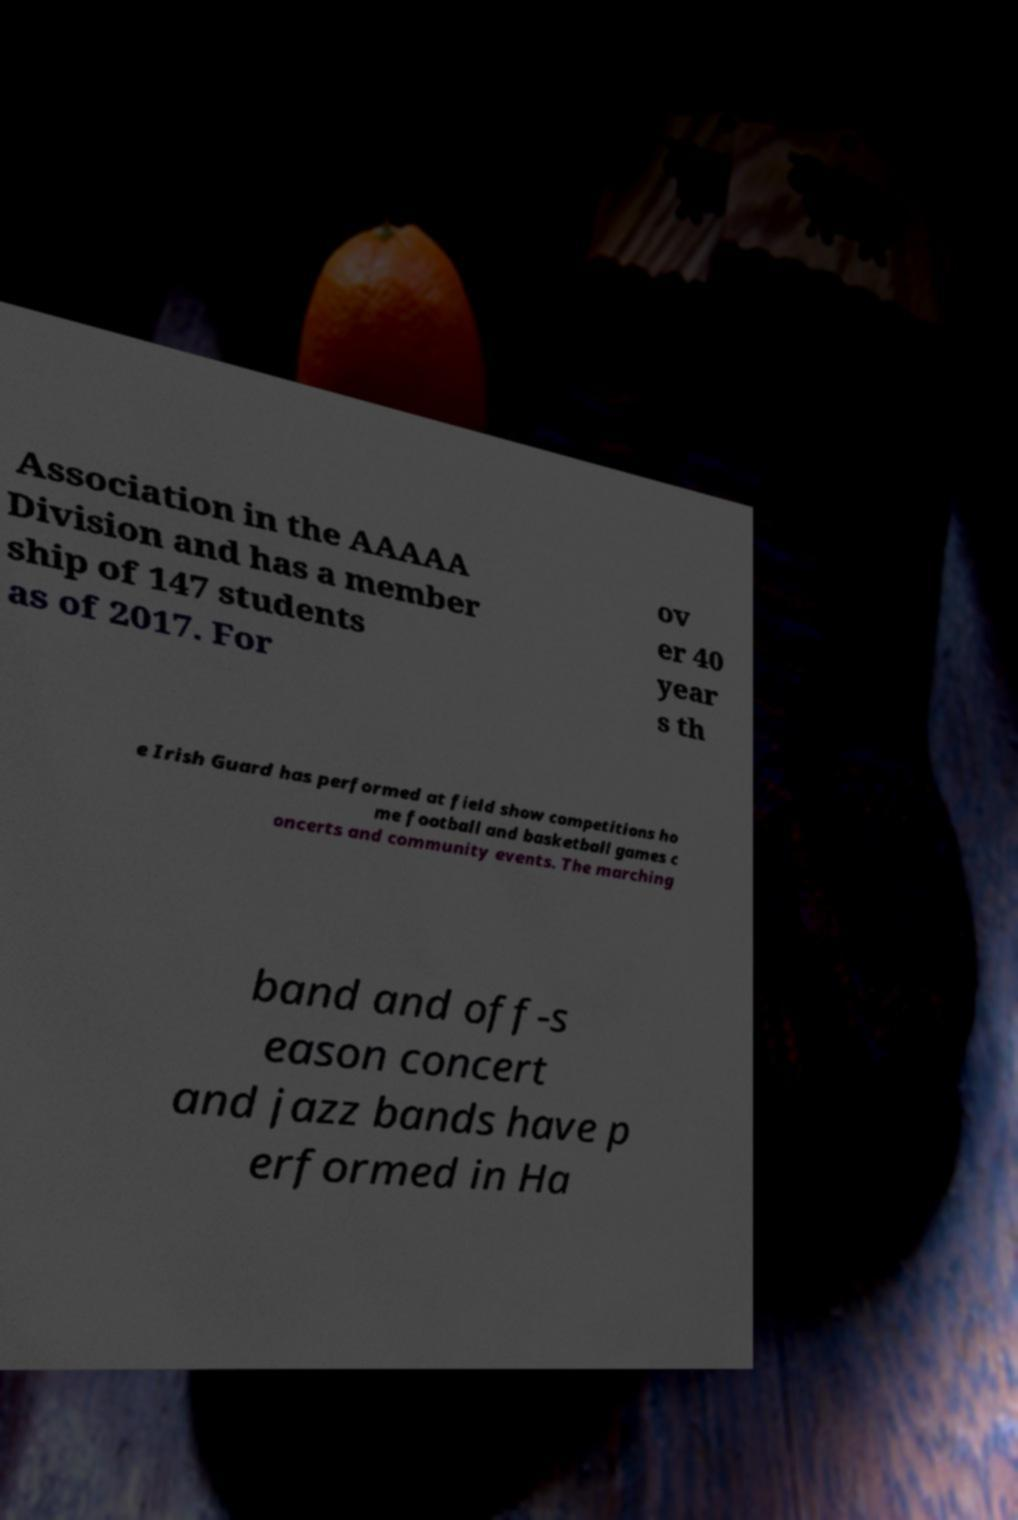For documentation purposes, I need the text within this image transcribed. Could you provide that? Association in the AAAAA Division and has a member ship of 147 students as of 2017. For ov er 40 year s th e Irish Guard has performed at field show competitions ho me football and basketball games c oncerts and community events. The marching band and off-s eason concert and jazz bands have p erformed in Ha 